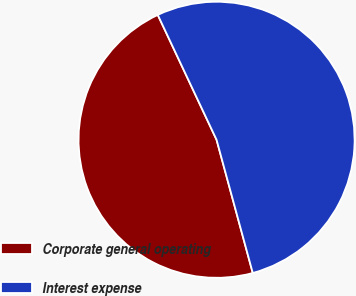Convert chart to OTSL. <chart><loc_0><loc_0><loc_500><loc_500><pie_chart><fcel>Corporate general operating<fcel>Interest expense<nl><fcel>47.22%<fcel>52.78%<nl></chart> 